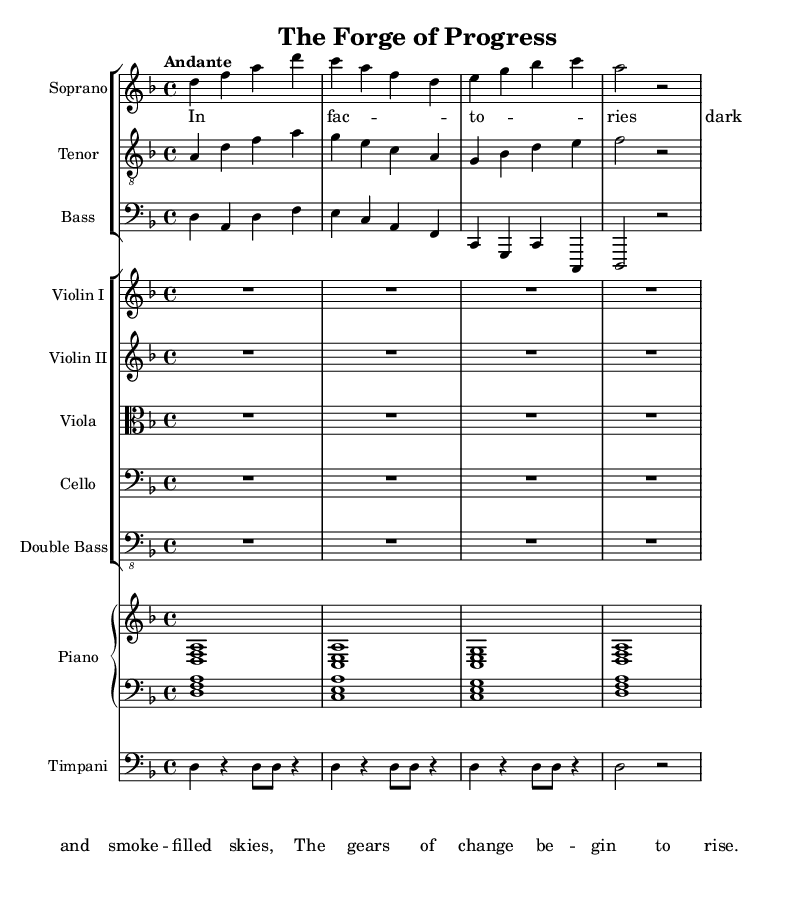What is the key signature of this music? The key signature is indicated by the sharp or flat symbols at the beginning of the staff. In the provided score, there are no sharps or flats, meaning it is in the key of D minor, which has one flat.
Answer: D minor What is the time signature of this piece? The time signature is shown at the beginning of the staff. It is expressed as a fraction, where the top number indicates the number of beats per measure, and the bottom number indicates the note value that receives one beat. In this score, it states 4/4, which signifies four beats per measure with the quarter note receiving one beat.
Answer: 4/4 What is the tempo of this composition? The tempo is indicated in words at the beginning of the score, guiding the speed of the music. In this case, it is labeled "Andante," which signifies a moderately slow tempo, typically around 76-108 beats per minute.
Answer: Andante How many staves are present in the score? The number of staves can be determined visually by counting the separate staff groups. In this score, there are two staff groups for the vocal parts and one staff group for the orchestral instruments, totaling six staves.
Answer: Six What does the first verse describe? The lyrics provided in the verse section can be analyzed for their content. The first verse depicts the scenes of factories and the transformation due to industry, with imagery of dark skies filled with smoke and the rise of the gears of change.
Answer: Factories, change What is the role of the timpani in the composition? To determine the role of the timpani, we examine how it is integrated within the score. In the provided code, the timpani plays a rhythmic and supporting role in the background, focusing on establishing a strong pulse that complements the vocal sections.
Answer: Rhythmic support Which instruments are included in the orchestral section? The orchestral section is defined by the lines labeled "Violin I," "Violin II," "Viola," "Cello," and "Double Bass." By reviewing these instrument names, we can identify that these are the string instruments included.
Answer: Violin I, Violin II, Viola, Cello, Double Bass 